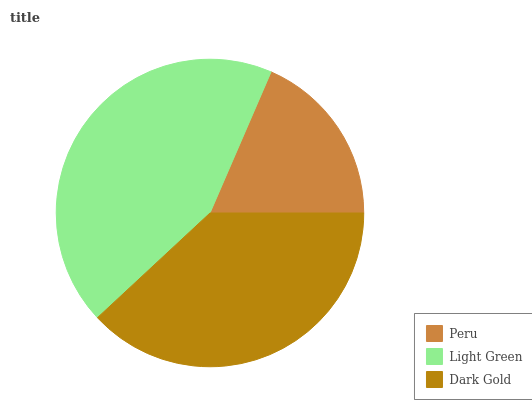Is Peru the minimum?
Answer yes or no. Yes. Is Light Green the maximum?
Answer yes or no. Yes. Is Dark Gold the minimum?
Answer yes or no. No. Is Dark Gold the maximum?
Answer yes or no. No. Is Light Green greater than Dark Gold?
Answer yes or no. Yes. Is Dark Gold less than Light Green?
Answer yes or no. Yes. Is Dark Gold greater than Light Green?
Answer yes or no. No. Is Light Green less than Dark Gold?
Answer yes or no. No. Is Dark Gold the high median?
Answer yes or no. Yes. Is Dark Gold the low median?
Answer yes or no. Yes. Is Light Green the high median?
Answer yes or no. No. Is Peru the low median?
Answer yes or no. No. 